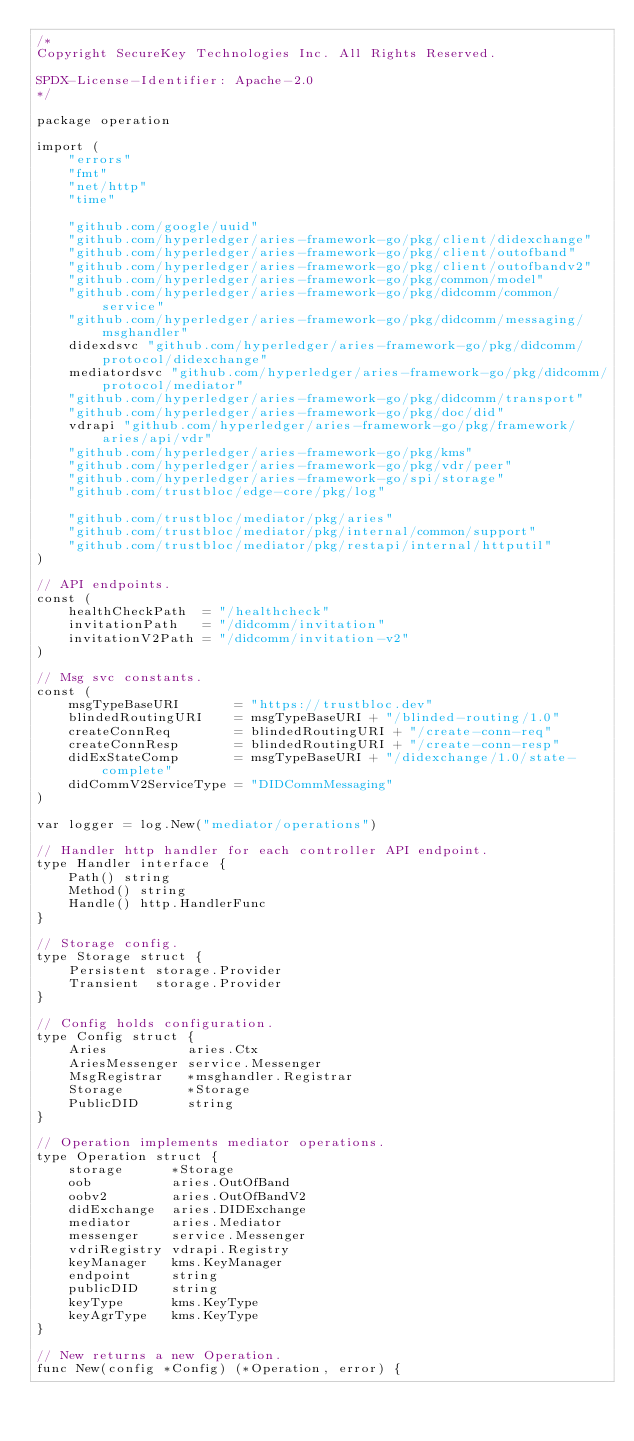<code> <loc_0><loc_0><loc_500><loc_500><_Go_>/*
Copyright SecureKey Technologies Inc. All Rights Reserved.

SPDX-License-Identifier: Apache-2.0
*/

package operation

import (
	"errors"
	"fmt"
	"net/http"
	"time"

	"github.com/google/uuid"
	"github.com/hyperledger/aries-framework-go/pkg/client/didexchange"
	"github.com/hyperledger/aries-framework-go/pkg/client/outofband"
	"github.com/hyperledger/aries-framework-go/pkg/client/outofbandv2"
	"github.com/hyperledger/aries-framework-go/pkg/common/model"
	"github.com/hyperledger/aries-framework-go/pkg/didcomm/common/service"
	"github.com/hyperledger/aries-framework-go/pkg/didcomm/messaging/msghandler"
	didexdsvc "github.com/hyperledger/aries-framework-go/pkg/didcomm/protocol/didexchange"
	mediatordsvc "github.com/hyperledger/aries-framework-go/pkg/didcomm/protocol/mediator"
	"github.com/hyperledger/aries-framework-go/pkg/didcomm/transport"
	"github.com/hyperledger/aries-framework-go/pkg/doc/did"
	vdrapi "github.com/hyperledger/aries-framework-go/pkg/framework/aries/api/vdr"
	"github.com/hyperledger/aries-framework-go/pkg/kms"
	"github.com/hyperledger/aries-framework-go/pkg/vdr/peer"
	"github.com/hyperledger/aries-framework-go/spi/storage"
	"github.com/trustbloc/edge-core/pkg/log"

	"github.com/trustbloc/mediator/pkg/aries"
	"github.com/trustbloc/mediator/pkg/internal/common/support"
	"github.com/trustbloc/mediator/pkg/restapi/internal/httputil"
)

// API endpoints.
const (
	healthCheckPath  = "/healthcheck"
	invitationPath   = "/didcomm/invitation"
	invitationV2Path = "/didcomm/invitation-v2"
)

// Msg svc constants.
const (
	msgTypeBaseURI       = "https://trustbloc.dev"
	blindedRoutingURI    = msgTypeBaseURI + "/blinded-routing/1.0"
	createConnReq        = blindedRoutingURI + "/create-conn-req"
	createConnResp       = blindedRoutingURI + "/create-conn-resp"
	didExStateComp       = msgTypeBaseURI + "/didexchange/1.0/state-complete"
	didCommV2ServiceType = "DIDCommMessaging"
)

var logger = log.New("mediator/operations")

// Handler http handler for each controller API endpoint.
type Handler interface {
	Path() string
	Method() string
	Handle() http.HandlerFunc
}

// Storage config.
type Storage struct {
	Persistent storage.Provider
	Transient  storage.Provider
}

// Config holds configuration.
type Config struct {
	Aries          aries.Ctx
	AriesMessenger service.Messenger
	MsgRegistrar   *msghandler.Registrar
	Storage        *Storage
	PublicDID      string
}

// Operation implements mediator operations.
type Operation struct {
	storage      *Storage
	oob          aries.OutOfBand
	oobv2        aries.OutOfBandV2
	didExchange  aries.DIDExchange
	mediator     aries.Mediator
	messenger    service.Messenger
	vdriRegistry vdrapi.Registry
	keyManager   kms.KeyManager
	endpoint     string
	publicDID    string
	keyType      kms.KeyType
	keyAgrType   kms.KeyType
}

// New returns a new Operation.
func New(config *Config) (*Operation, error) {</code> 